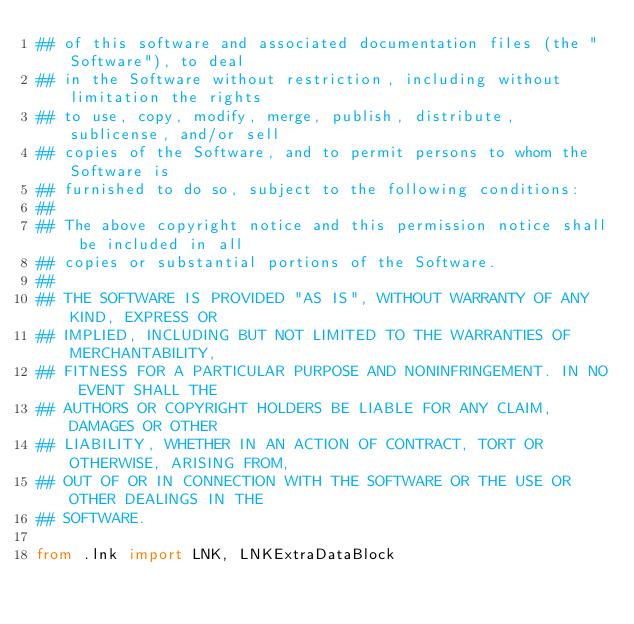Convert code to text. <code><loc_0><loc_0><loc_500><loc_500><_Python_>## of this software and associated documentation files (the "Software"), to deal
## in the Software without restriction, including without limitation the rights
## to use, copy, modify, merge, publish, distribute, sublicense, and/or sell
## copies of the Software, and to permit persons to whom the Software is
## furnished to do so, subject to the following conditions:
## 
## The above copyright notice and this permission notice shall be included in all
## copies or substantial portions of the Software.
## 
## THE SOFTWARE IS PROVIDED "AS IS", WITHOUT WARRANTY OF ANY KIND, EXPRESS OR
## IMPLIED, INCLUDING BUT NOT LIMITED TO THE WARRANTIES OF MERCHANTABILITY,
## FITNESS FOR A PARTICULAR PURPOSE AND NONINFRINGEMENT. IN NO EVENT SHALL THE
## AUTHORS OR COPYRIGHT HOLDERS BE LIABLE FOR ANY CLAIM, DAMAGES OR OTHER
## LIABILITY, WHETHER IN AN ACTION OF CONTRACT, TORT OR OTHERWISE, ARISING FROM,
## OUT OF OR IN CONNECTION WITH THE SOFTWARE OR THE USE OR OTHER DEALINGS IN THE
## SOFTWARE.

from .lnk import LNK, LNKExtraDataBlock
</code> 